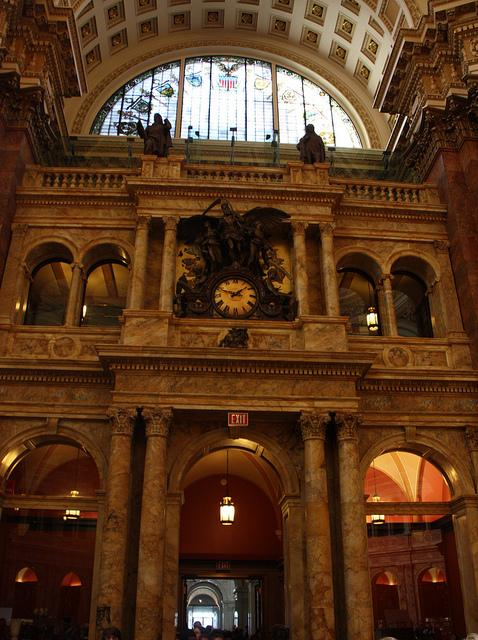What ensigns are shown at the top most part of this building?

Choices:
A) coatsof arms
B) fleursdi lis
C) clocks
D) flags coatsof arms 